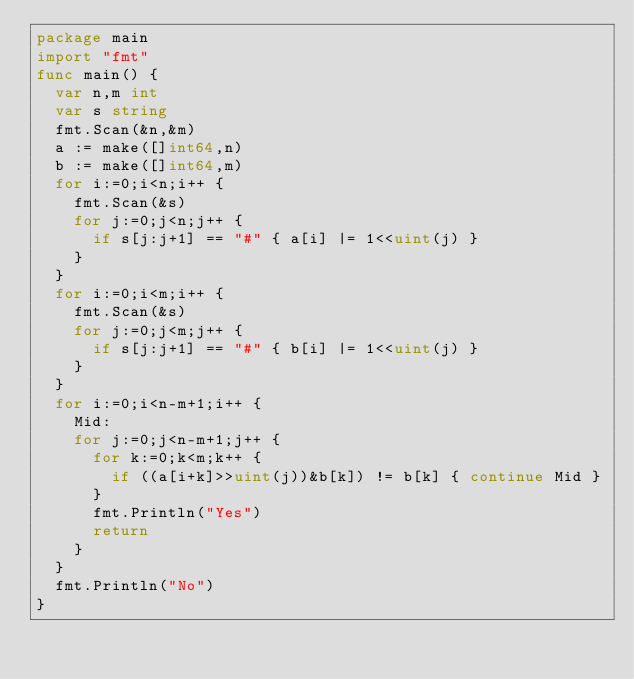<code> <loc_0><loc_0><loc_500><loc_500><_Go_>package main
import "fmt"
func main() {
  var n,m int
  var s string
  fmt.Scan(&n,&m)
  a := make([]int64,n)
  b := make([]int64,m)
  for i:=0;i<n;i++ {
    fmt.Scan(&s)
    for j:=0;j<n;j++ {
      if s[j:j+1] == "#" { a[i] |= 1<<uint(j) }
    }
  }
  for i:=0;i<m;i++ {
    fmt.Scan(&s)
    for j:=0;j<m;j++ {
      if s[j:j+1] == "#" { b[i] |= 1<<uint(j) }
    }
  }
  for i:=0;i<n-m+1;i++ {
    Mid:
    for j:=0;j<n-m+1;j++ {
      for k:=0;k<m;k++ {
        if ((a[i+k]>>uint(j))&b[k]) != b[k] { continue Mid }
      }
      fmt.Println("Yes")
      return
    }
  }
  fmt.Println("No")
}</code> 